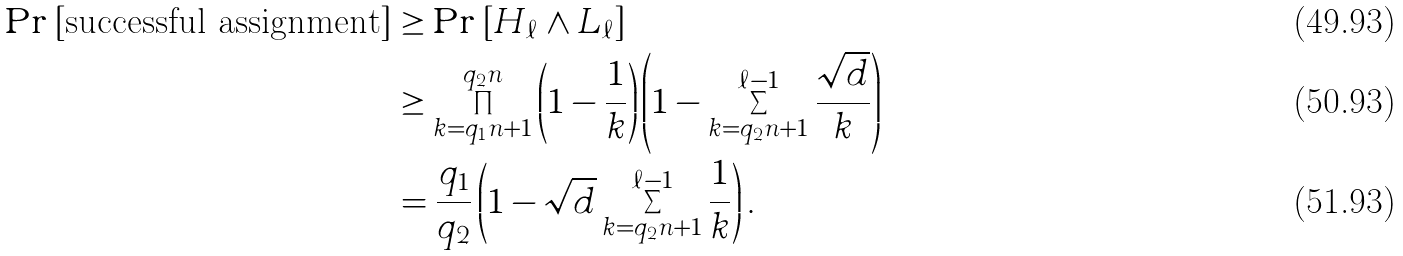Convert formula to latex. <formula><loc_0><loc_0><loc_500><loc_500>\Pr \left [ \text {successful assignment} \right ] & \geq \Pr \left [ H _ { \ell } \wedge L _ { \ell } \right ] \\ & \geq \prod _ { k = q _ { 1 } n + 1 } ^ { q _ { 2 } n } \left ( 1 - \frac { 1 } { k } \right ) \left ( 1 - \sum _ { k = q _ { 2 } n + 1 } ^ { \ell - 1 } { \frac { \sqrt { d } } { k } } \right ) \\ & = \frac { q _ { 1 } } { q _ { 2 } } \left ( 1 - \sqrt { d } \sum _ { k = q _ { 2 } n + 1 } ^ { \ell - 1 } \frac { 1 } { k } \right ) .</formula> 